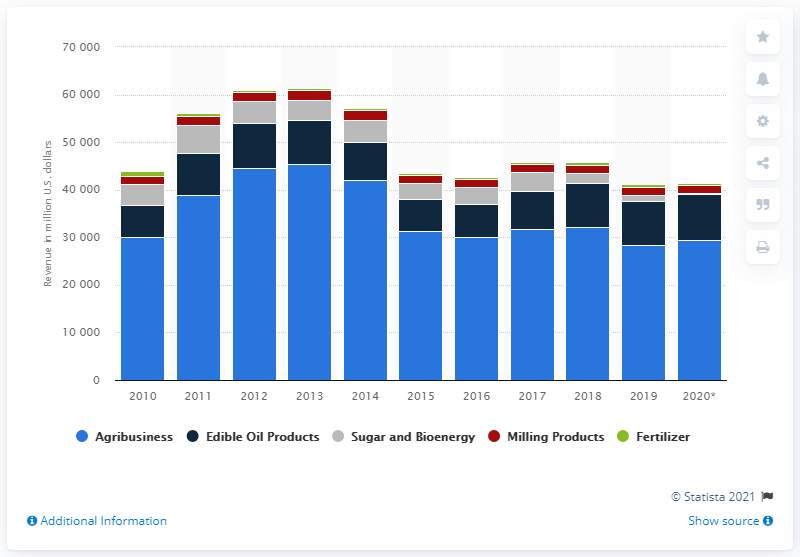Indicate a few pertinent items in this graphic. Bunge Limited's agribusiness segment reported net sales of approximately 32,206 in 2018. 